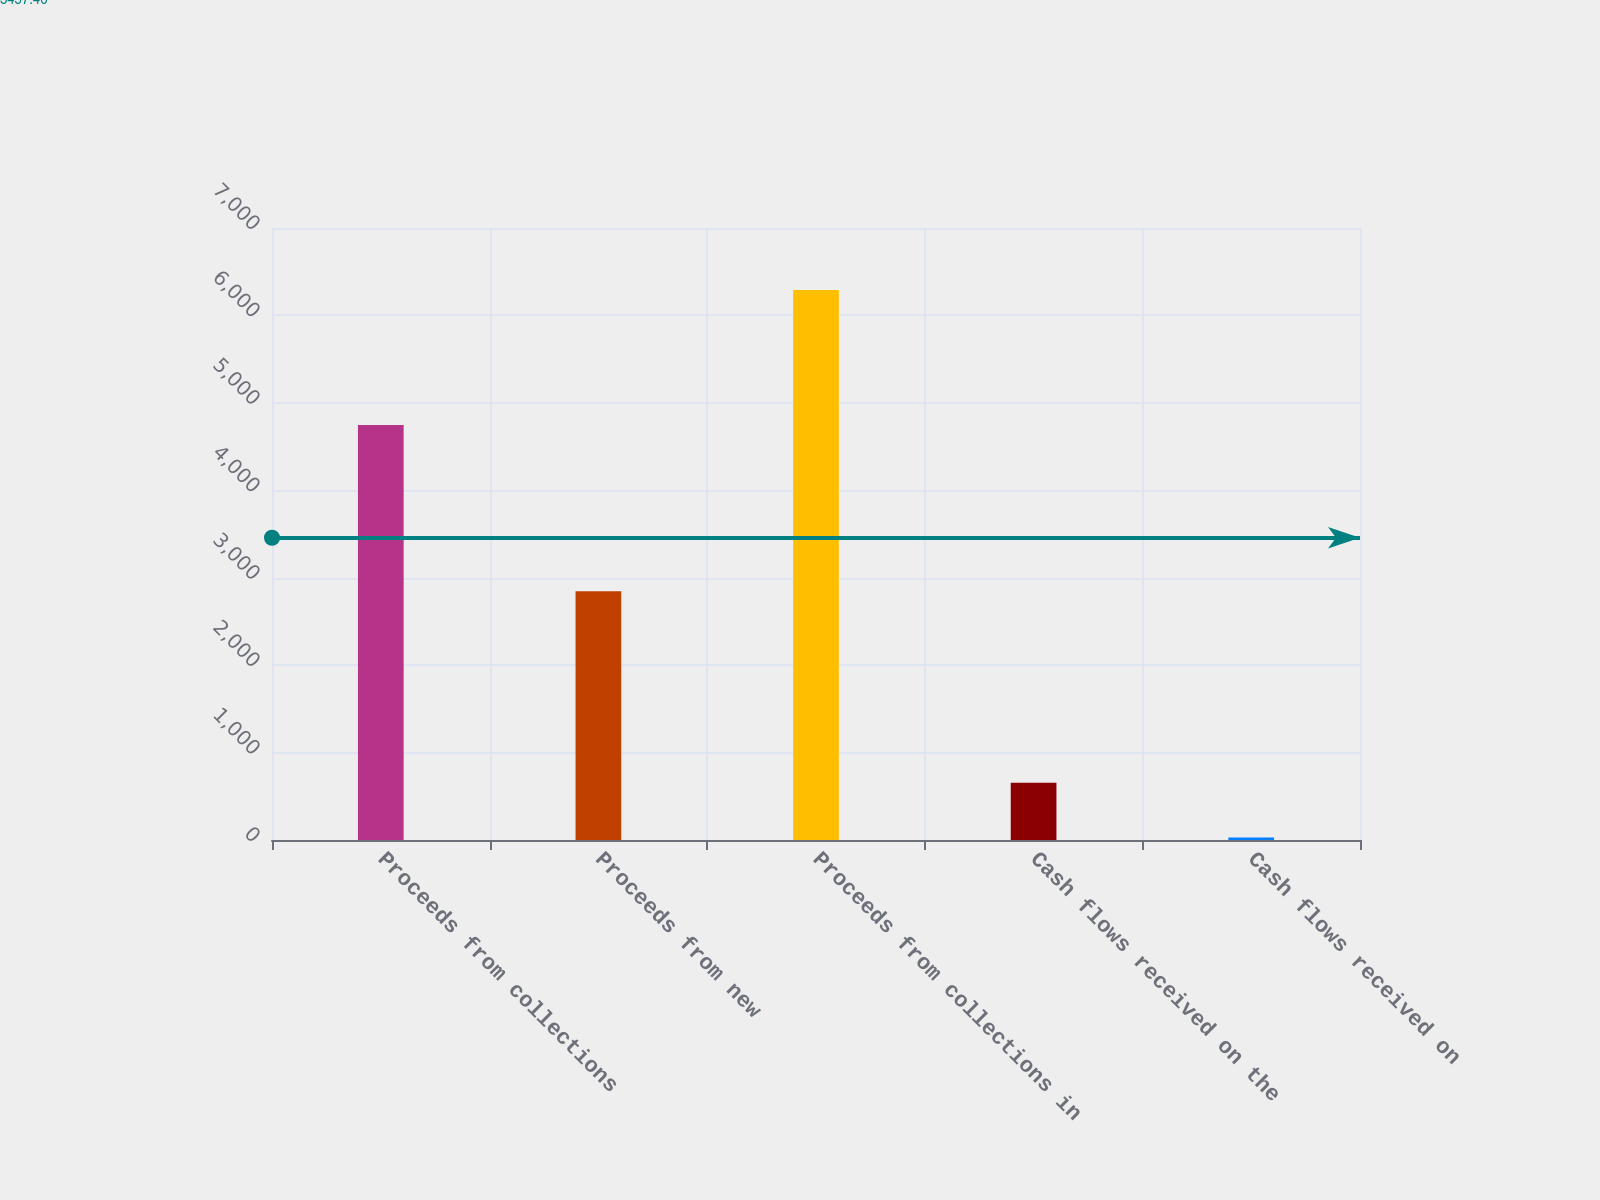<chart> <loc_0><loc_0><loc_500><loc_500><bar_chart><fcel>Proceeds from collections<fcel>Proceeds from new<fcel>Proceeds from collections in<fcel>Cash flows received on the<fcel>Cash flows received on<nl><fcel>4748.1<fcel>2844.4<fcel>6290.6<fcel>655.52<fcel>29.4<nl></chart> 